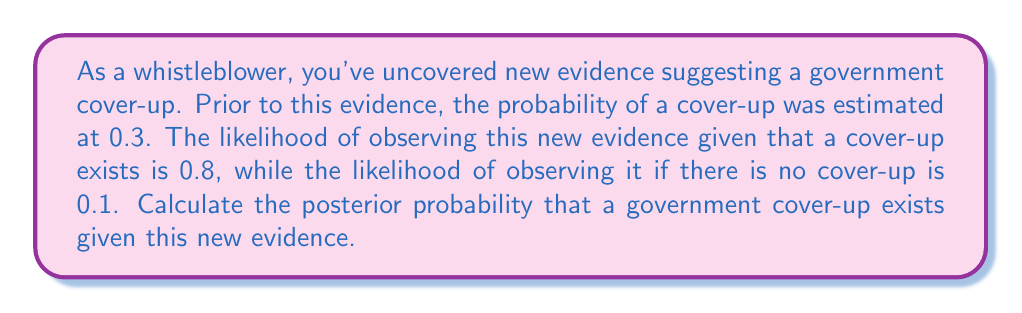Give your solution to this math problem. To solve this problem, we'll use Bayes' theorem:

$$P(A|B) = \frac{P(B|A) \cdot P(A)}{P(B)}$$

Where:
$A$ = Event of a government cover-up
$B$ = Observing the new evidence

Given:
$P(A)$ = 0.3 (prior probability of a cover-up)
$P(B|A)$ = 0.8 (likelihood of evidence given a cover-up)
$P(B|\neg A)$ = 0.1 (likelihood of evidence given no cover-up)

Step 1: Calculate $P(B)$ using the law of total probability:
$$P(B) = P(B|A) \cdot P(A) + P(B|\neg A) \cdot P(\neg A)$$
$$P(B) = 0.8 \cdot 0.3 + 0.1 \cdot 0.7 = 0.24 + 0.07 = 0.31$$

Step 2: Apply Bayes' theorem:
$$P(A|B) = \frac{P(B|A) \cdot P(A)}{P(B)}$$
$$P(A|B) = \frac{0.8 \cdot 0.3}{0.31} = \frac{0.24}{0.31} \approx 0.7742$$

Therefore, the posterior probability of a government cover-up given the new evidence is approximately 0.7742 or 77.42%.
Answer: 0.7742 (or 77.42%) 